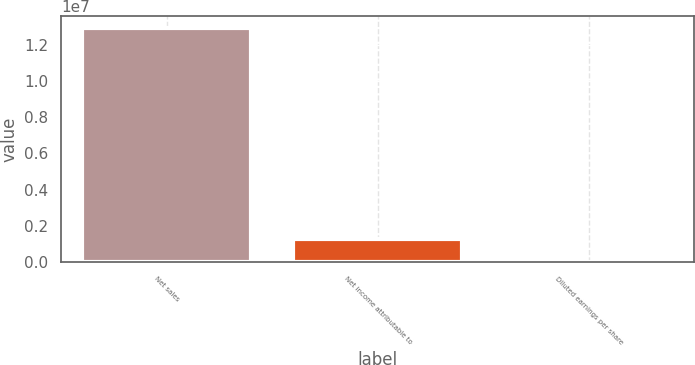Convert chart to OTSL. <chart><loc_0><loc_0><loc_500><loc_500><bar_chart><fcel>Net sales<fcel>Net income attributable to<fcel>Diluted earnings per share<nl><fcel>1.29358e+07<fcel>1.29359e+06<fcel>7.58<nl></chart> 